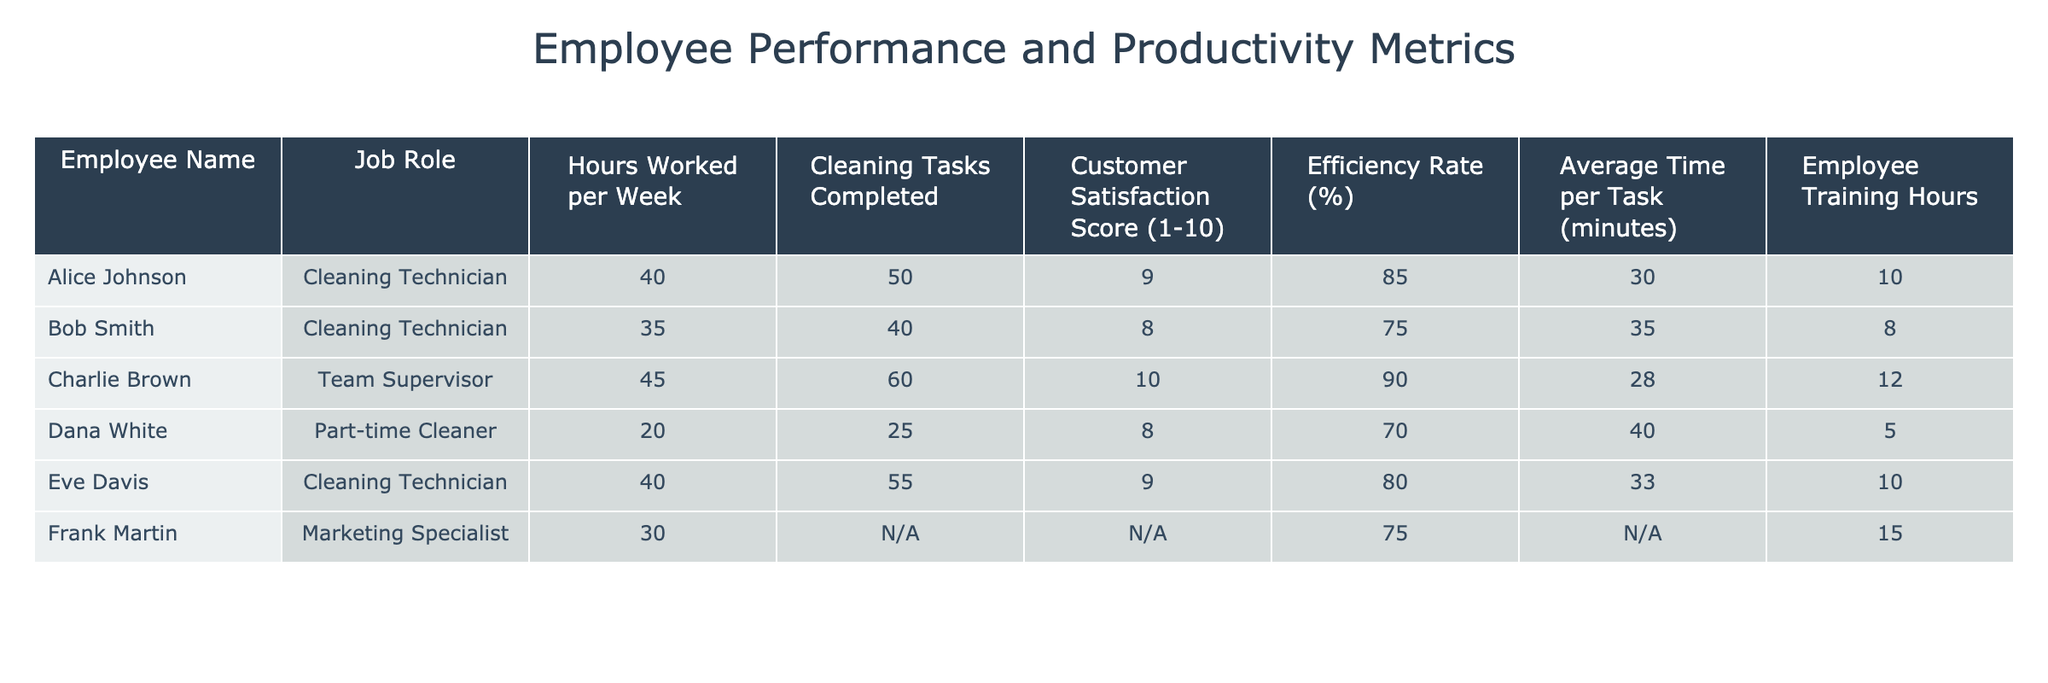What is the highest Customer Satisfaction Score? The highest Customer Satisfaction Score in the table is found in the row for Charlie Brown, who has a score of 10.
Answer: 10 What is the average Efficiency Rate of all Cleaning Technicians? The Efficiency Rates for the Cleaning Technicians are 85% (Alice), 75% (Bob), 90% (Charlie), and 80% (Eve). To calculate the average, sum these values: 85 + 75 + 90 + 80 = 330. There are 4 technicians, so the average is 330 / 4 = 82.5%.
Answer: 82.5% Did any employee work more than 40 hours a week? Yes, Charlie Brown worked 45 hours a week, which is more than 40 hours.
Answer: Yes What is the total number of Cleaning Tasks Completed by all employees? The cleaning tasks completed are 50 (Alice) + 40 (Bob) + 60 (Charlie) + 25 (Dana) + 55 (Eve) = 230 tasks in total.
Answer: 230 Who has the lowest Average Time per Task? Dana White has the lowest Average Time per Task of 40 minutes.
Answer: 40 minutes What is the difference in the Customer Satisfaction Scores between the highest and lowest scores? The highest Customer Satisfaction Score is 10 (Charlie), and the lowest score is 8 (Bob and Dana). The difference is 10 - 8 = 2.
Answer: 2 What is the total number of Employee Training Hours across all employees? The Employee Training Hours are: 10 (Alice) + 8 (Bob) + 12 (Charlie) + 5 (Dana) + 10 (Eve) + 15 (Frank) = 60 hours in total.
Answer: 60 hours Which employee had the highest Efficiency Rate, and what was the rate? Charlie Brown had the highest Efficiency Rate at 90%.
Answer: 90% 